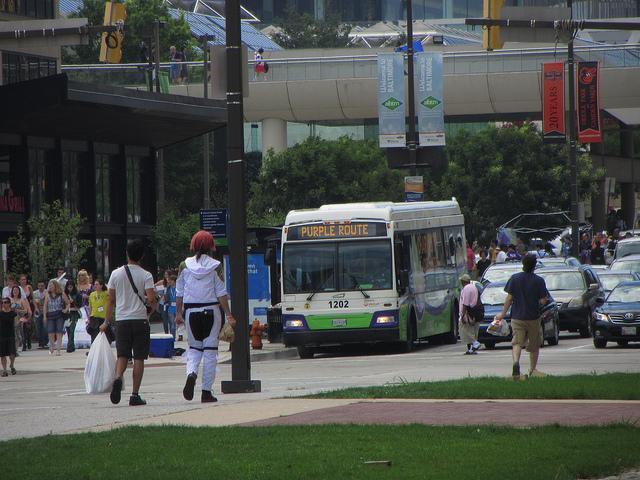How many people can be seen?
Give a very brief answer. 4. How many cars can be seen?
Give a very brief answer. 2. How many horses are there?
Give a very brief answer. 0. 